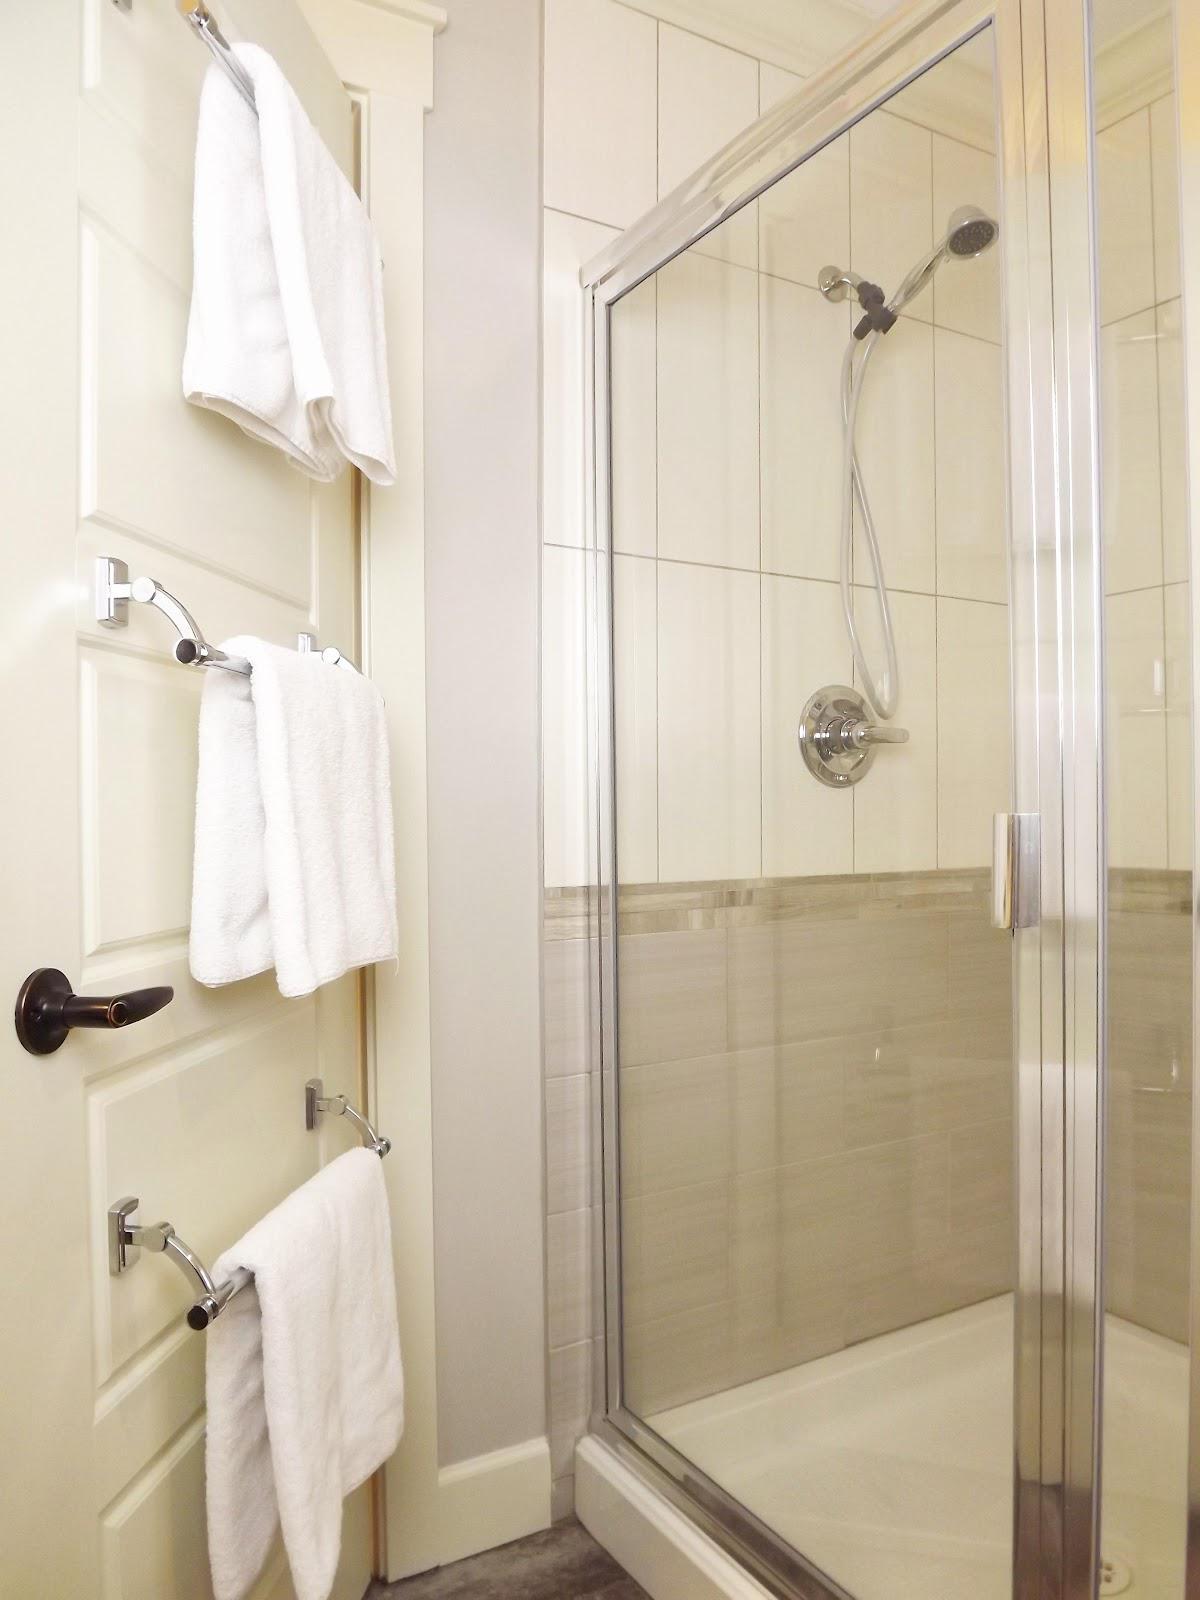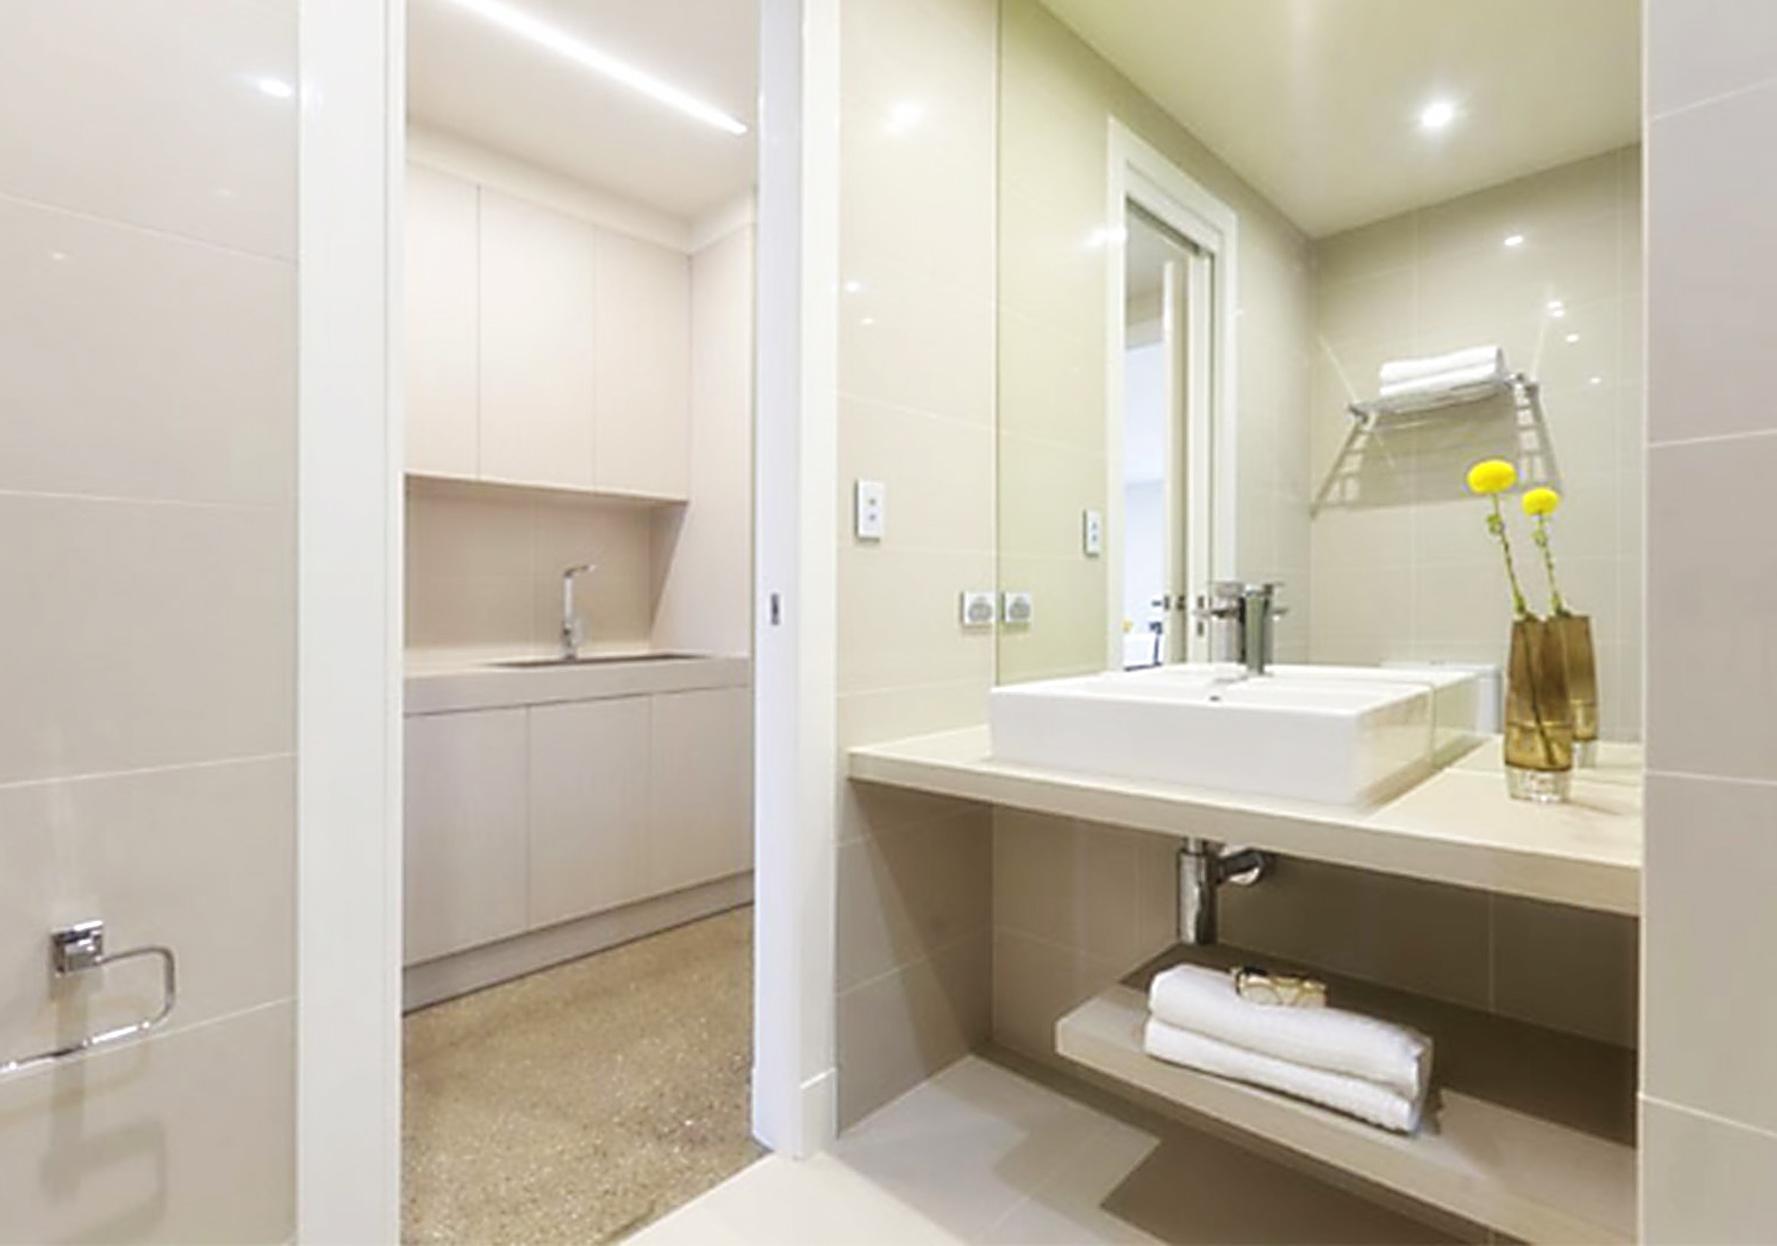The first image is the image on the left, the second image is the image on the right. For the images displayed, is the sentence "In the image to the right, there are flowers on the bathroom counter." factually correct? Answer yes or no. Yes. The first image is the image on the left, the second image is the image on the right. Considering the images on both sides, is "There is no more than three towels." valid? Answer yes or no. No. 